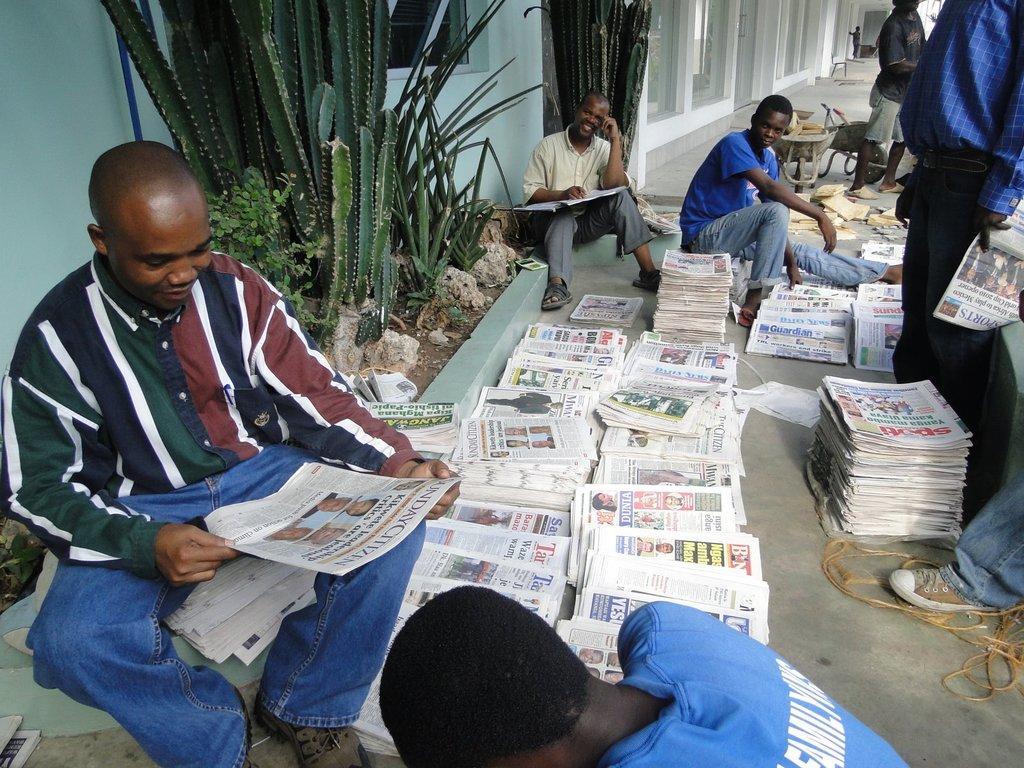In one or two sentences, can you explain what this image depicts? Here we can see plants, people, newspapers, rope and things. Beside these plants there is a wall and glass windows. 